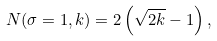Convert formula to latex. <formula><loc_0><loc_0><loc_500><loc_500>N ( \sigma = 1 , k ) = 2 \left ( \sqrt { 2 k } - 1 \right ) ,</formula> 